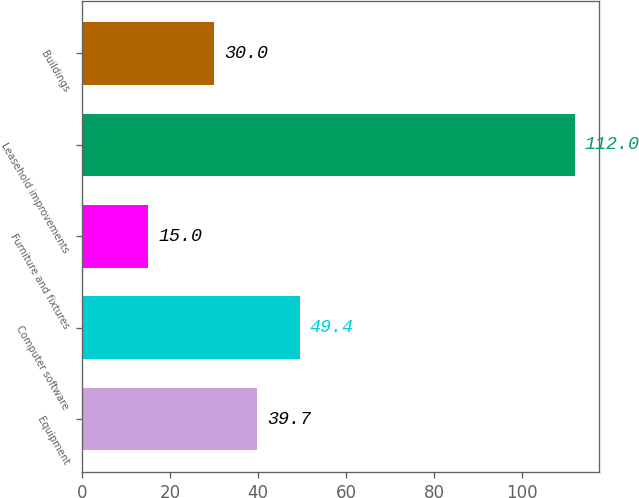<chart> <loc_0><loc_0><loc_500><loc_500><bar_chart><fcel>Equipment<fcel>Computer software<fcel>Furniture and fixtures<fcel>Leasehold improvements<fcel>Buildings<nl><fcel>39.7<fcel>49.4<fcel>15<fcel>112<fcel>30<nl></chart> 